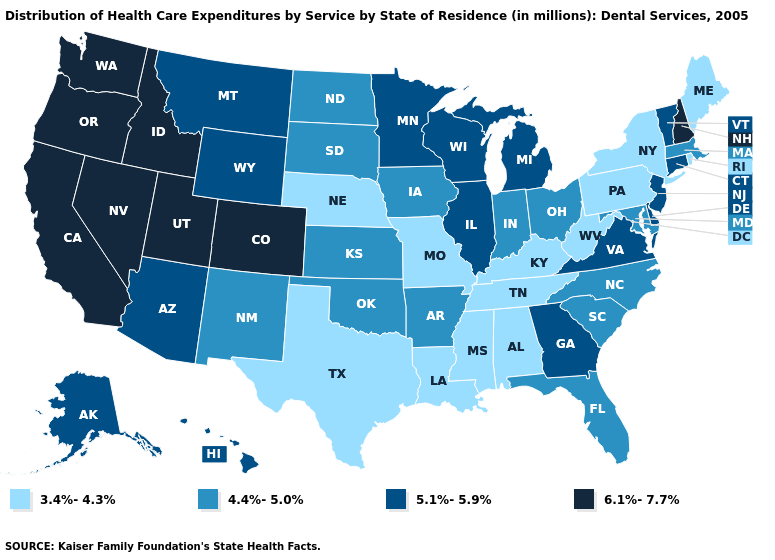What is the value of Kansas?
Write a very short answer. 4.4%-5.0%. What is the lowest value in the West?
Answer briefly. 4.4%-5.0%. What is the value of Illinois?
Short answer required. 5.1%-5.9%. What is the value of Indiana?
Write a very short answer. 4.4%-5.0%. Name the states that have a value in the range 3.4%-4.3%?
Write a very short answer. Alabama, Kentucky, Louisiana, Maine, Mississippi, Missouri, Nebraska, New York, Pennsylvania, Rhode Island, Tennessee, Texas, West Virginia. Does Mississippi have the same value as New York?
Quick response, please. Yes. Which states hav the highest value in the South?
Concise answer only. Delaware, Georgia, Virginia. What is the highest value in the South ?
Answer briefly. 5.1%-5.9%. Name the states that have a value in the range 3.4%-4.3%?
Give a very brief answer. Alabama, Kentucky, Louisiana, Maine, Mississippi, Missouri, Nebraska, New York, Pennsylvania, Rhode Island, Tennessee, Texas, West Virginia. What is the highest value in states that border Idaho?
Answer briefly. 6.1%-7.7%. Name the states that have a value in the range 5.1%-5.9%?
Answer briefly. Alaska, Arizona, Connecticut, Delaware, Georgia, Hawaii, Illinois, Michigan, Minnesota, Montana, New Jersey, Vermont, Virginia, Wisconsin, Wyoming. Among the states that border Nebraska , which have the highest value?
Quick response, please. Colorado. What is the value of California?
Short answer required. 6.1%-7.7%. What is the lowest value in the MidWest?
Keep it brief. 3.4%-4.3%. Does Louisiana have the highest value in the USA?
Quick response, please. No. 